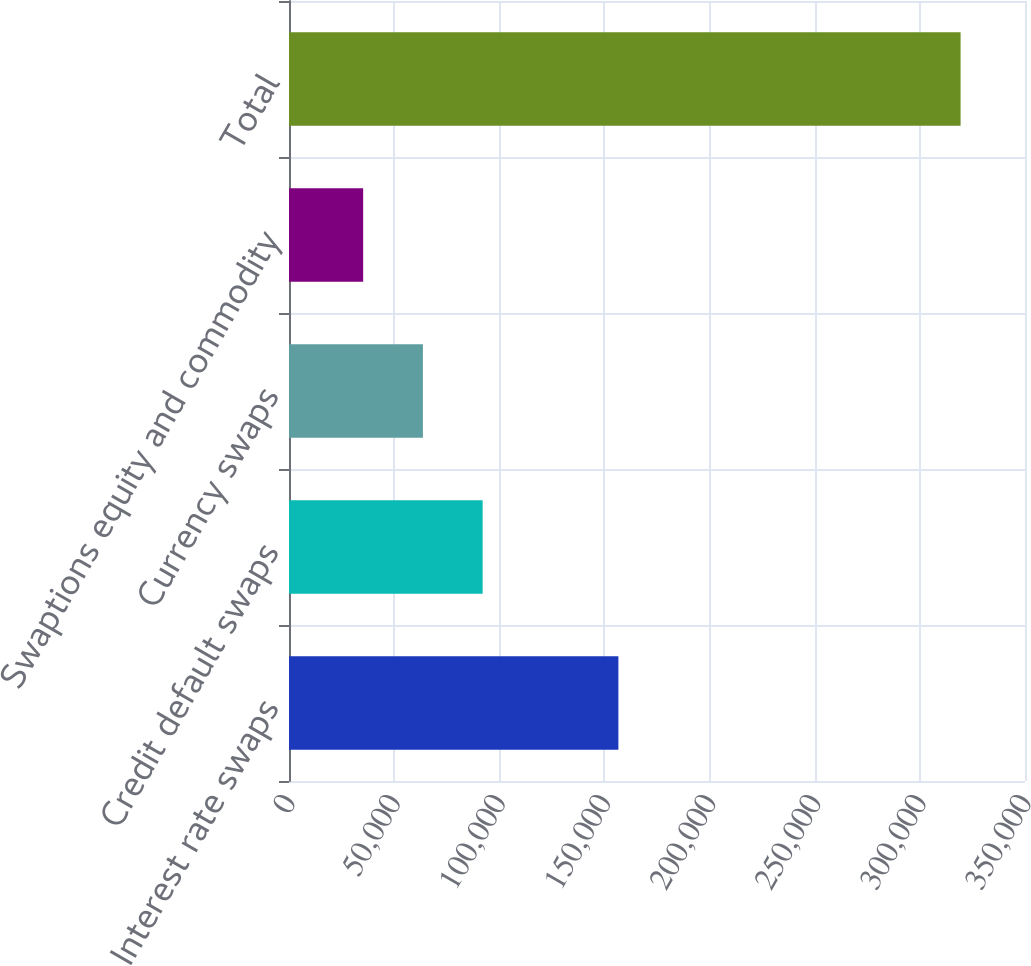<chart> <loc_0><loc_0><loc_500><loc_500><bar_chart><fcel>Interest rate swaps<fcel>Credit default swaps<fcel>Currency swaps<fcel>Swaptions equity and commodity<fcel>Total<nl><fcel>156634<fcel>92090.2<fcel>63680.1<fcel>35270<fcel>319371<nl></chart> 